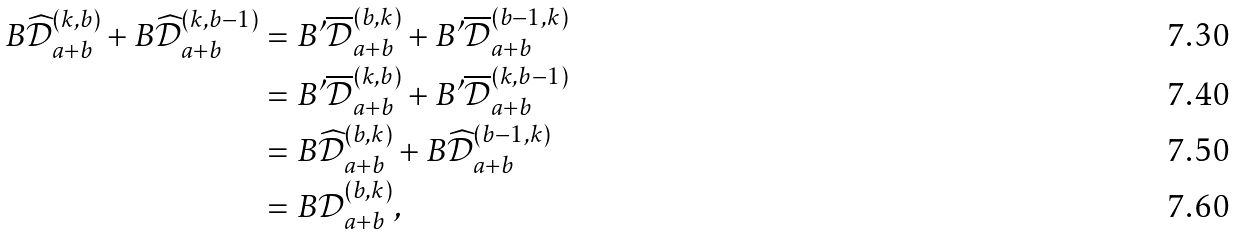Convert formula to latex. <formula><loc_0><loc_0><loc_500><loc_500>B \widehat { \mathcal { D } } _ { a + b } ^ { ( k , b ) } + B \widehat { \mathcal { D } } _ { a + b } ^ { ( k , b - 1 ) } & = B ^ { \prime } \overline { \mathcal { D } } _ { a + b } ^ { ( b , k ) } + B ^ { \prime } \overline { \mathcal { D } } _ { a + b } ^ { ( b - 1 , k ) } \\ & = B ^ { \prime } \overline { \mathcal { D } } _ { a + b } ^ { ( k , b ) } + B ^ { \prime } \overline { \mathcal { D } } _ { a + b } ^ { ( k , b - 1 ) } \\ & = B \widehat { \mathcal { D } } _ { a + b } ^ { ( b , k ) } + B \widehat { \mathcal { D } } _ { a + b } ^ { ( b - 1 , k ) } \\ & = B \mathcal { D } _ { a + b } ^ { ( b , k ) } ,</formula> 